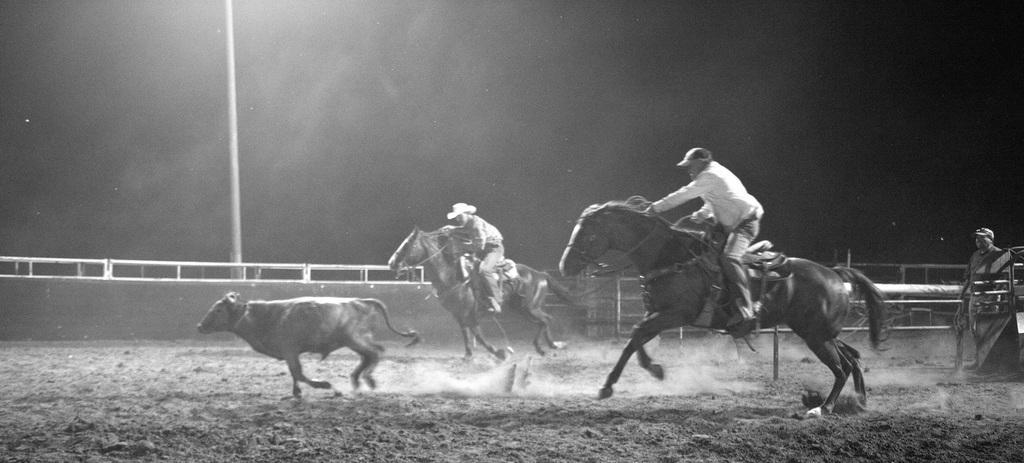Please provide a concise description of this image. In this image there are two persons riding horse on the ground one person is standing and seeing. There is a cow running on the ground. 